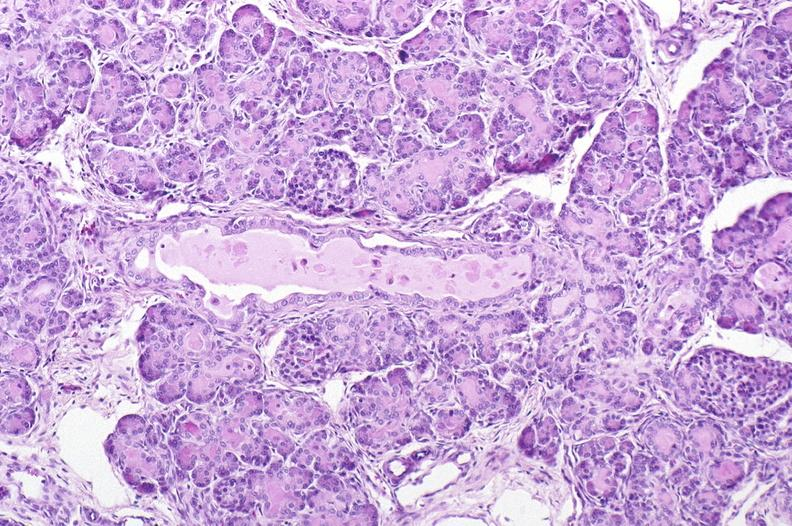s hearts present?
Answer the question using a single word or phrase. No 